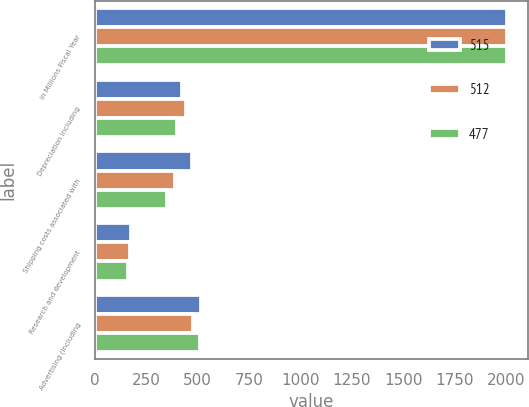Convert chart to OTSL. <chart><loc_0><loc_0><loc_500><loc_500><stacked_bar_chart><ecel><fcel>In Millions Fiscal Year<fcel>Depreciation including<fcel>Shipping costs associated with<fcel>Research and development<fcel>Advertising (including<nl><fcel>515<fcel>2006<fcel>424<fcel>474<fcel>173<fcel>515<nl><fcel>512<fcel>2005<fcel>443<fcel>388<fcel>168<fcel>477<nl><fcel>477<fcel>2004<fcel>399<fcel>352<fcel>158<fcel>512<nl></chart> 